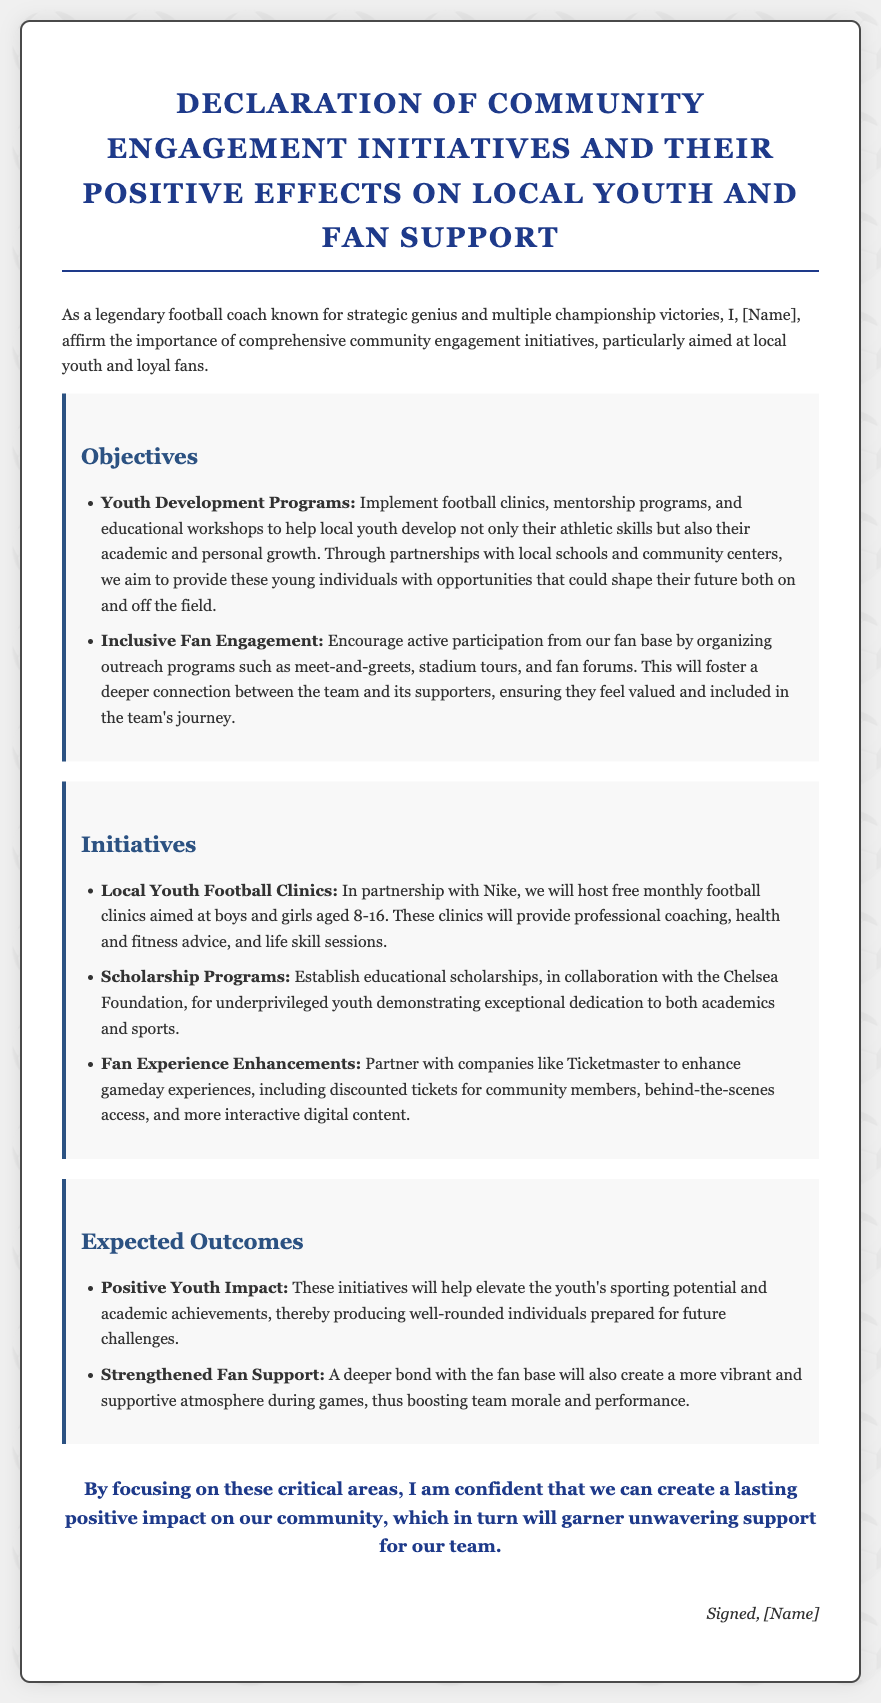What are the main objectives of the initiatives? The objectives outlined in the document are Youth Development Programs and Inclusive Fan Engagement.
Answer: Youth Development Programs, Inclusive Fan Engagement Who is the partner for the local youth football clinics? The document states that the local youth football clinics are in partnership with Nike.
Answer: Nike What age group is targeted for the youth football clinics? The clinics are aimed at boys and girls aged 8-16.
Answer: 8-16 What type of support will the scholarship programs provide? The scholarship programs will provide educational scholarships.
Answer: Educational scholarships What is one expected outcome related to youth? The expected outcome is a positive youth impact, helping youth elevate their sporting potential and academic achievements.
Answer: Positive youth impact What enhances the fan experience on game days? The document mentions enhancements like discounted tickets for community members.
Answer: Discounted tickets How will these initiatives affect team morale? The initiatives are expected to create a more vibrant and supportive atmosphere, thus boosting team morale.
Answer: Boosting team morale What foundation collaborates on the scholarship programs? The scholarship programs are established in collaboration with the Chelsea Foundation.
Answer: Chelsea Foundation 